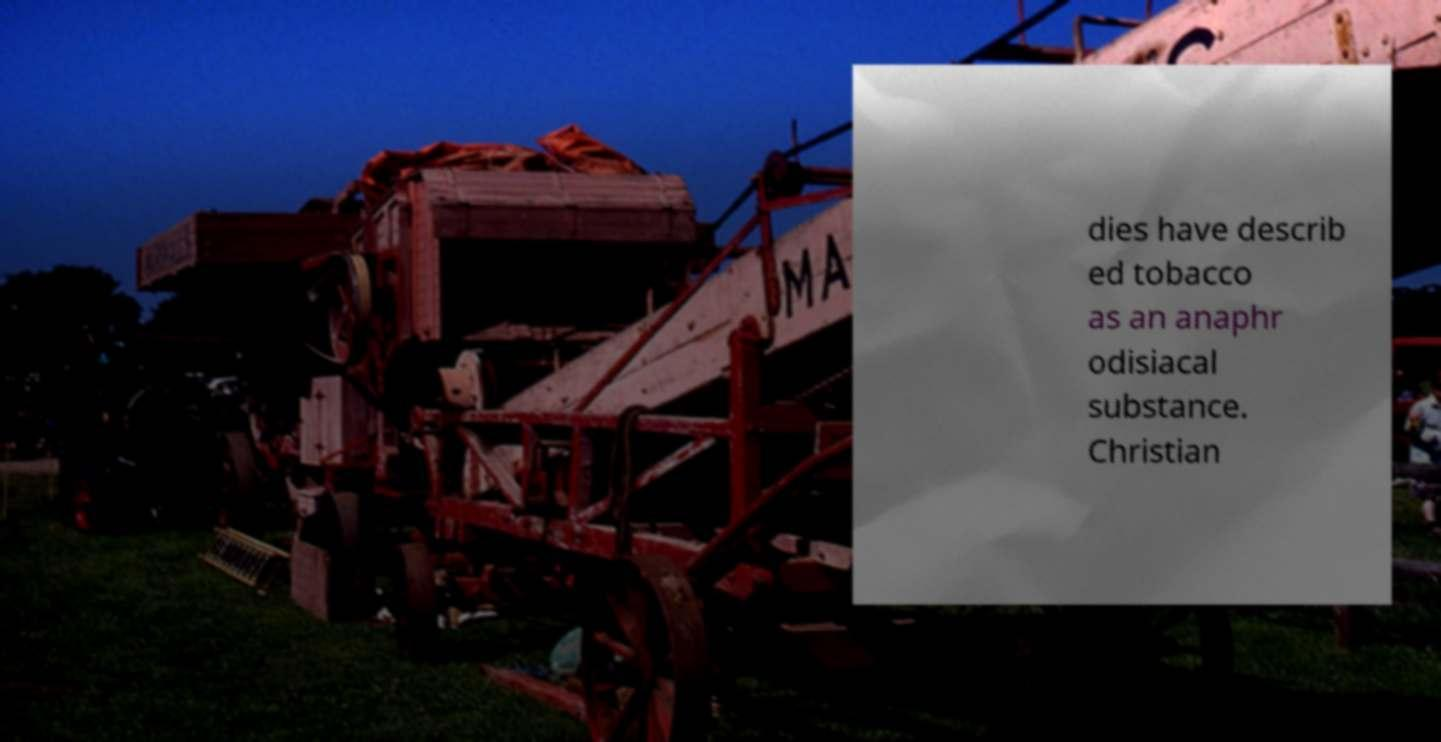Can you describe what kind of machine is shown in the image and its possible use? The machine in the image appears to be an old, possibly vintage, agricultural harvester used primarily for harvesting crops. The distinct features suggest it might be specialized, possibly even for specific crops like grain or corn, reflecting a historical context of agricultural machinery. 